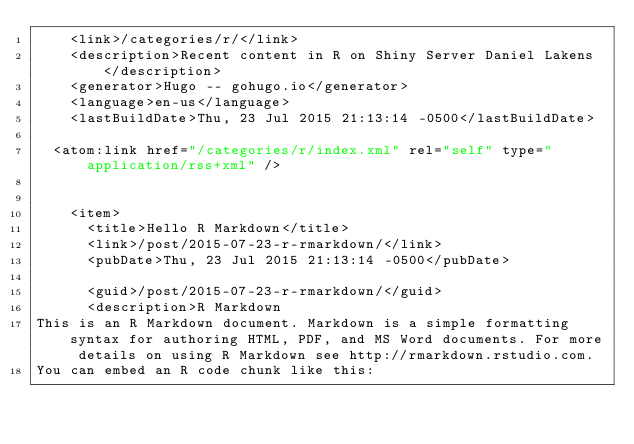<code> <loc_0><loc_0><loc_500><loc_500><_XML_>    <link>/categories/r/</link>
    <description>Recent content in R on Shiny Server Daniel Lakens</description>
    <generator>Hugo -- gohugo.io</generator>
    <language>en-us</language>
    <lastBuildDate>Thu, 23 Jul 2015 21:13:14 -0500</lastBuildDate>
    
	<atom:link href="/categories/r/index.xml" rel="self" type="application/rss+xml" />
    
    
    <item>
      <title>Hello R Markdown</title>
      <link>/post/2015-07-23-r-rmarkdown/</link>
      <pubDate>Thu, 23 Jul 2015 21:13:14 -0500</pubDate>
      
      <guid>/post/2015-07-23-r-rmarkdown/</guid>
      <description>R MarkdownThis is an R Markdown document. Markdown is a simple formatting syntax for authoring HTML, PDF, and MS Word documents. For more details on using R Markdown see http://rmarkdown.rstudio.com.
You can embed an R code chunk like this:</code> 